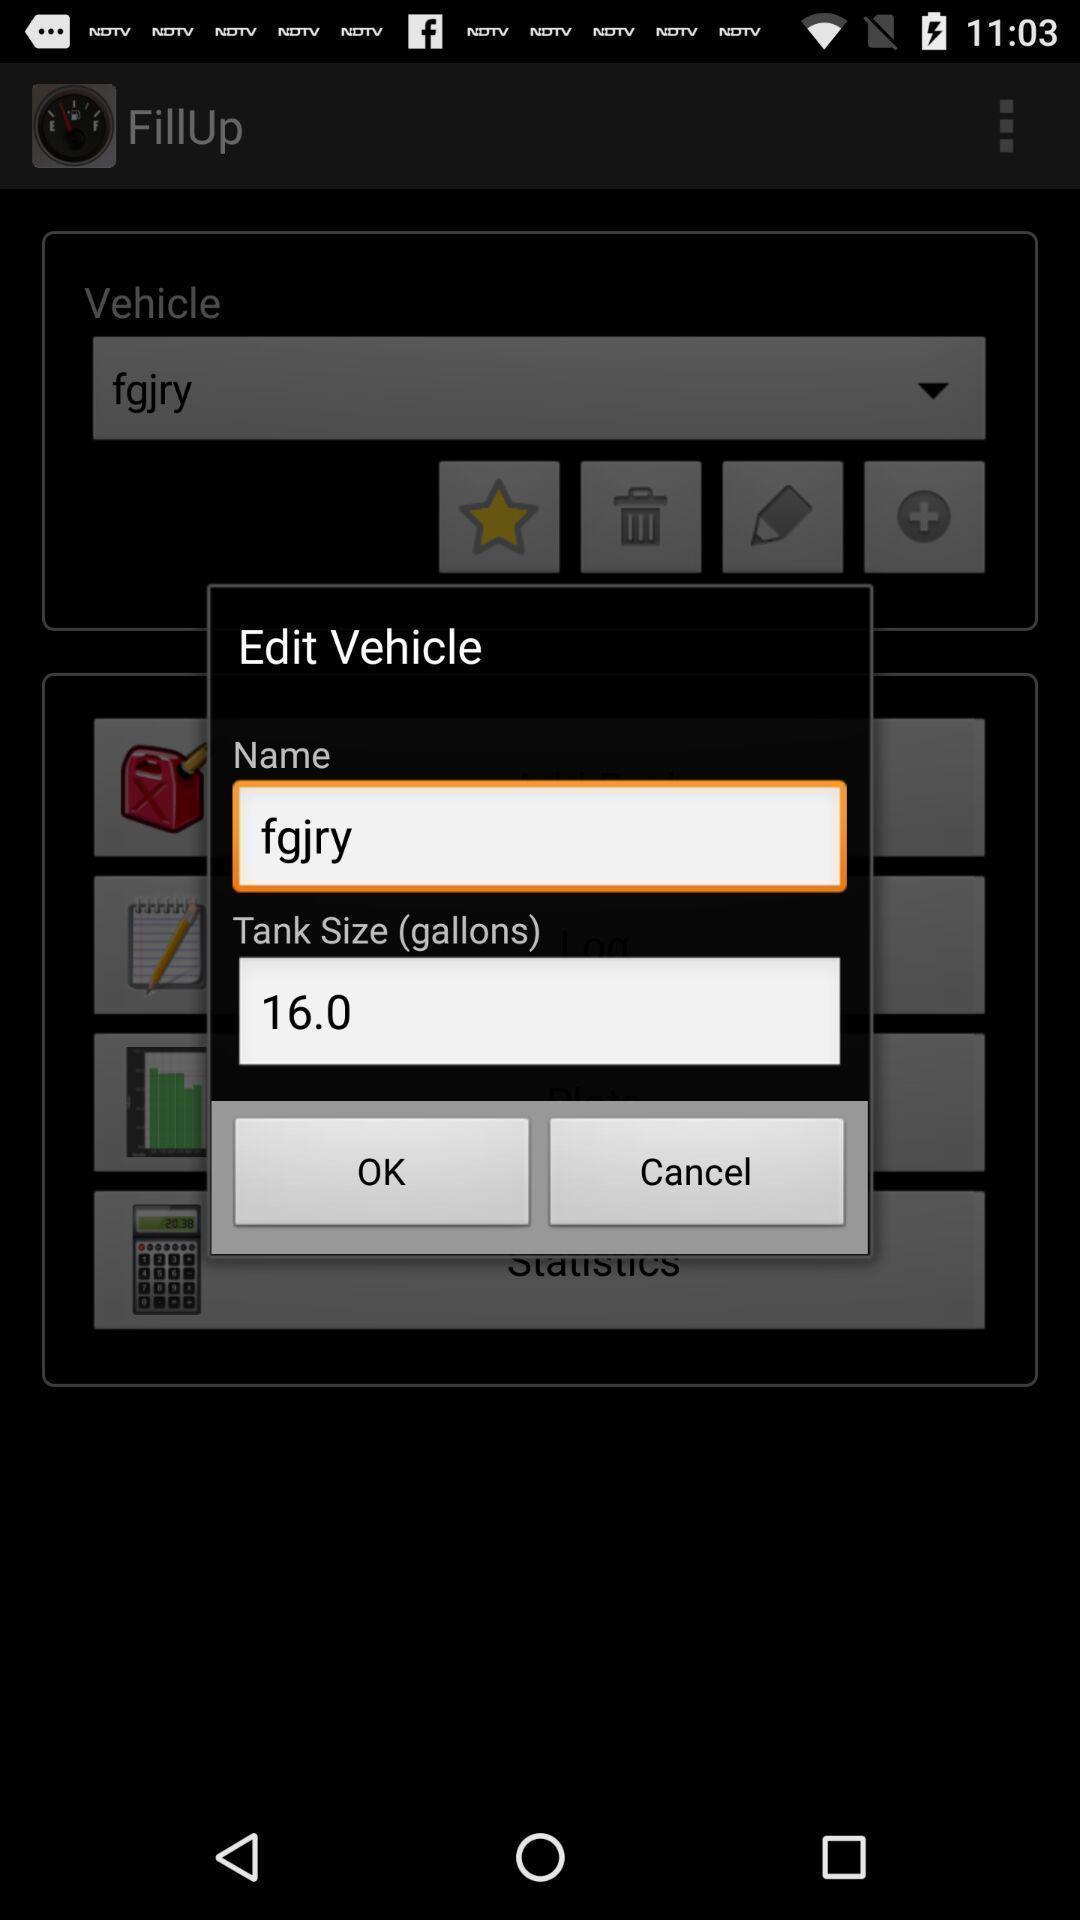What details can you identify in this image? Pop-up to edit vehicle details. 